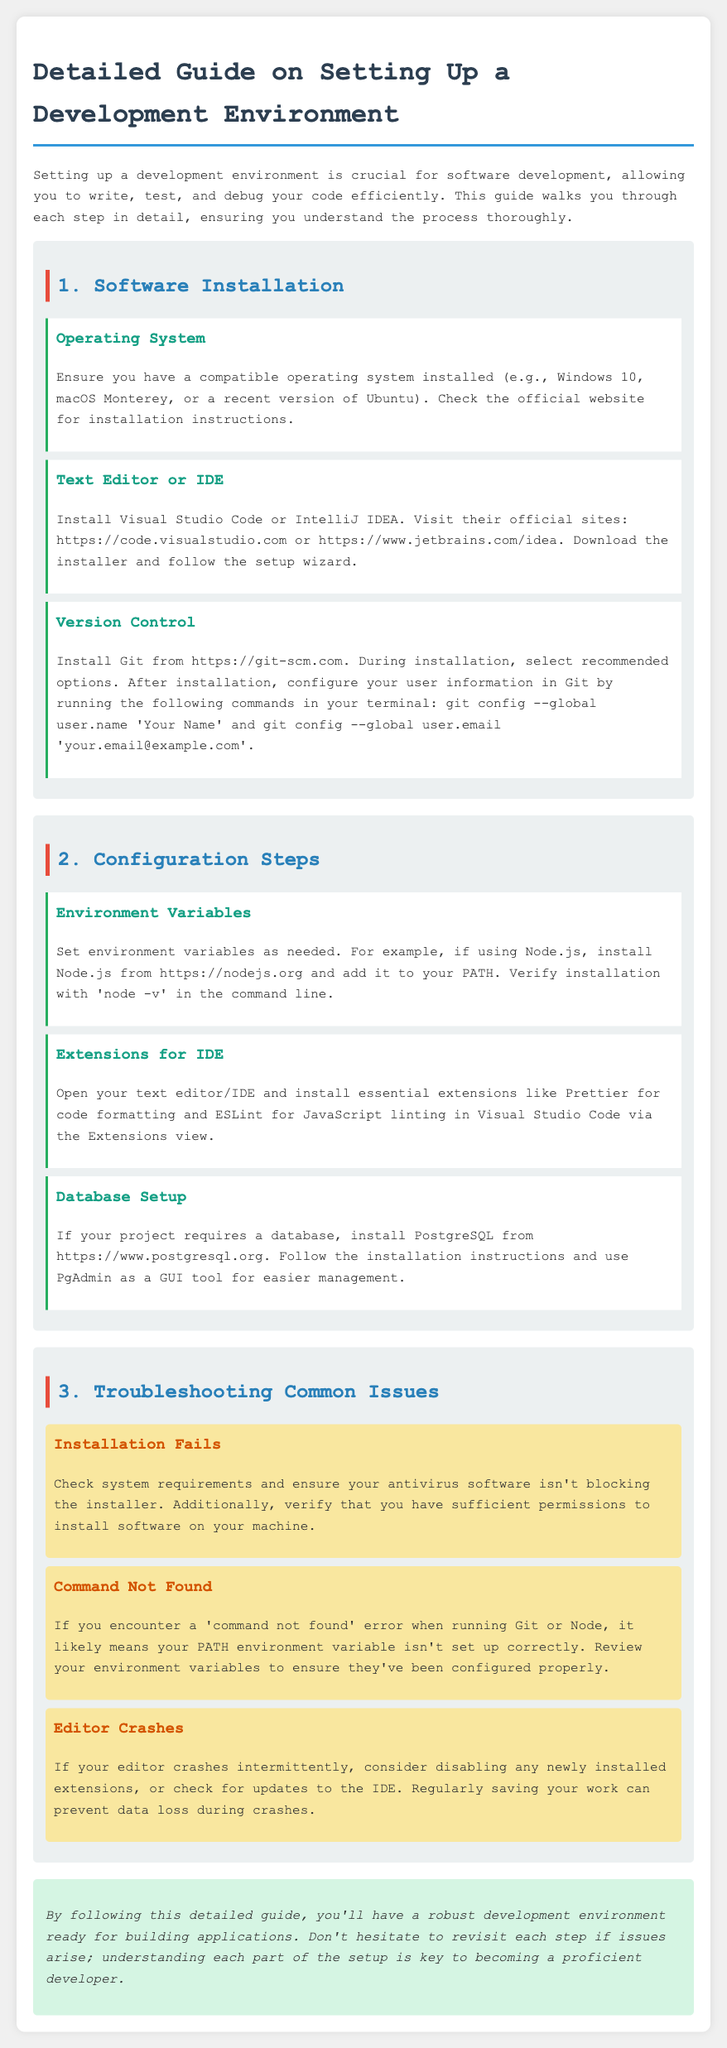What is the first step in setting up a development environment? The document outlines "Software Installation" as the first step in setting up a development environment.
Answer: Software Installation Which operating systems are mentioned as compatible? The document specifies three compatible operating systems: Windows 10, macOS Monterey, and recent versions of Ubuntu.
Answer: Windows 10, macOS Monterey, recent versions of Ubuntu What version control software is recommended? The guide suggests installing Git as the version control software.
Answer: Git What should be installed for database management? The document recommends installing PostgreSQL for database management.
Answer: PostgreSQL What common issue is related to installation failures? The document states that installation failures can often be due to insufficient permissions to install software on your machine.
Answer: Insufficient permissions What can cause a 'command not found' error? The document explains that a 'command not found' error can occur if the PATH environment variable isn't set up correctly.
Answer: PATH environment variable What extension is suggested for code formatting? The guide advises installing Prettier as an extension for code formatting in the IDE.
Answer: Prettier How should one verify Node.js installation? The document mentions verifying the Node.js installation by running 'node -v' in the command line.
Answer: 'node -v' in the command line 